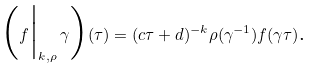<formula> <loc_0><loc_0><loc_500><loc_500>\Big ( f \Big | _ { k , \rho } \, \gamma \Big ) ( \tau ) = ( c \tau + d ) ^ { - k } \rho ( \gamma ^ { - 1 } ) f ( \gamma \tau ) \text {.}</formula> 